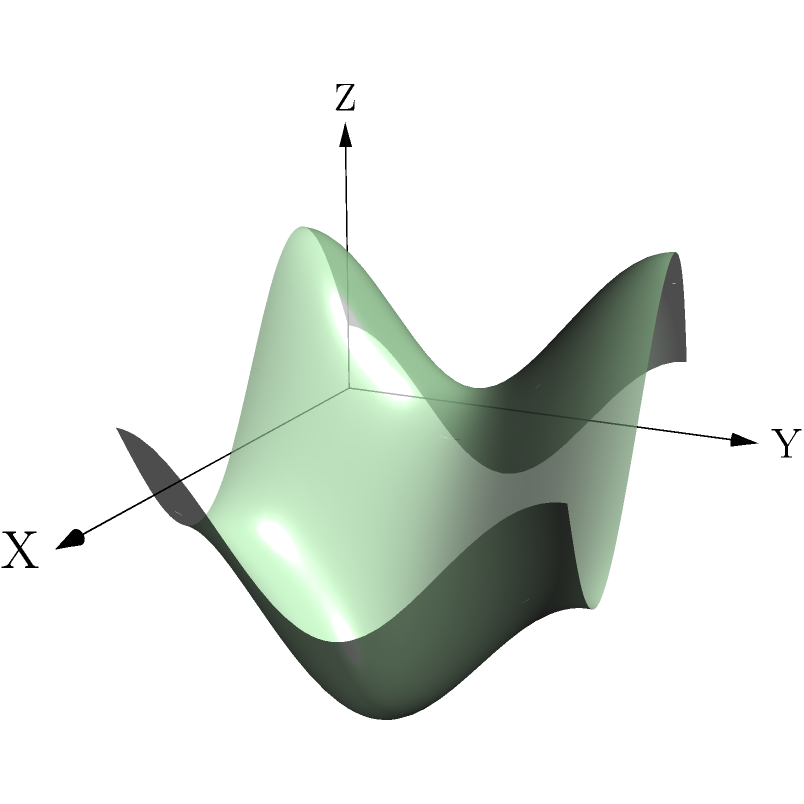Given the 3D coordinate system representing a lunar surface, where the Z-axis indicates elevation, and a rover path from (0,0,0) to (1,1,f(1,1)), what is the primary factor to consider when determining the optimal path for the lunar rover? To determine the optimal path for a lunar rover using a 3D coordinate system, we need to consider several factors:

1. Elevation changes: The Z-axis represents the elevation of the lunar surface. The optimal path should minimize extreme elevation changes to conserve energy and reduce the risk of tipping over.

2. Distance: The shortest path between two points is generally a straight line. However, in a 3D space with varying elevation, the shortest path may not always be the most efficient.

3. Obstacle avoidance: The lunar surface may have craters, boulders, or other obstacles that the rover needs to navigate around.

4. Energy consumption: The rover's energy usage is directly related to the path it takes. Steeper inclines require more energy to climb.

5. Terrain stability: Some areas of the lunar surface may be more stable than others, affecting the rover's traction and safety.

6. Scientific objectives: The path may need to include specific waypoints for scientific observations or sample collection.

Among these factors, the most critical one for determining the optimal path is the elevation change. This is because:

a) It directly impacts the rover's energy consumption.
b) Extreme elevation changes can pose safety risks to the rover.
c) It affects the rover's ability to maintain communication with the control center.
d) It influences the rover's speed and overall mission efficiency.

By prioritizing a path that minimizes drastic elevation changes while considering the other factors, we can ensure a safer, more energy-efficient, and ultimately more successful lunar exploration mission.
Answer: Elevation change 